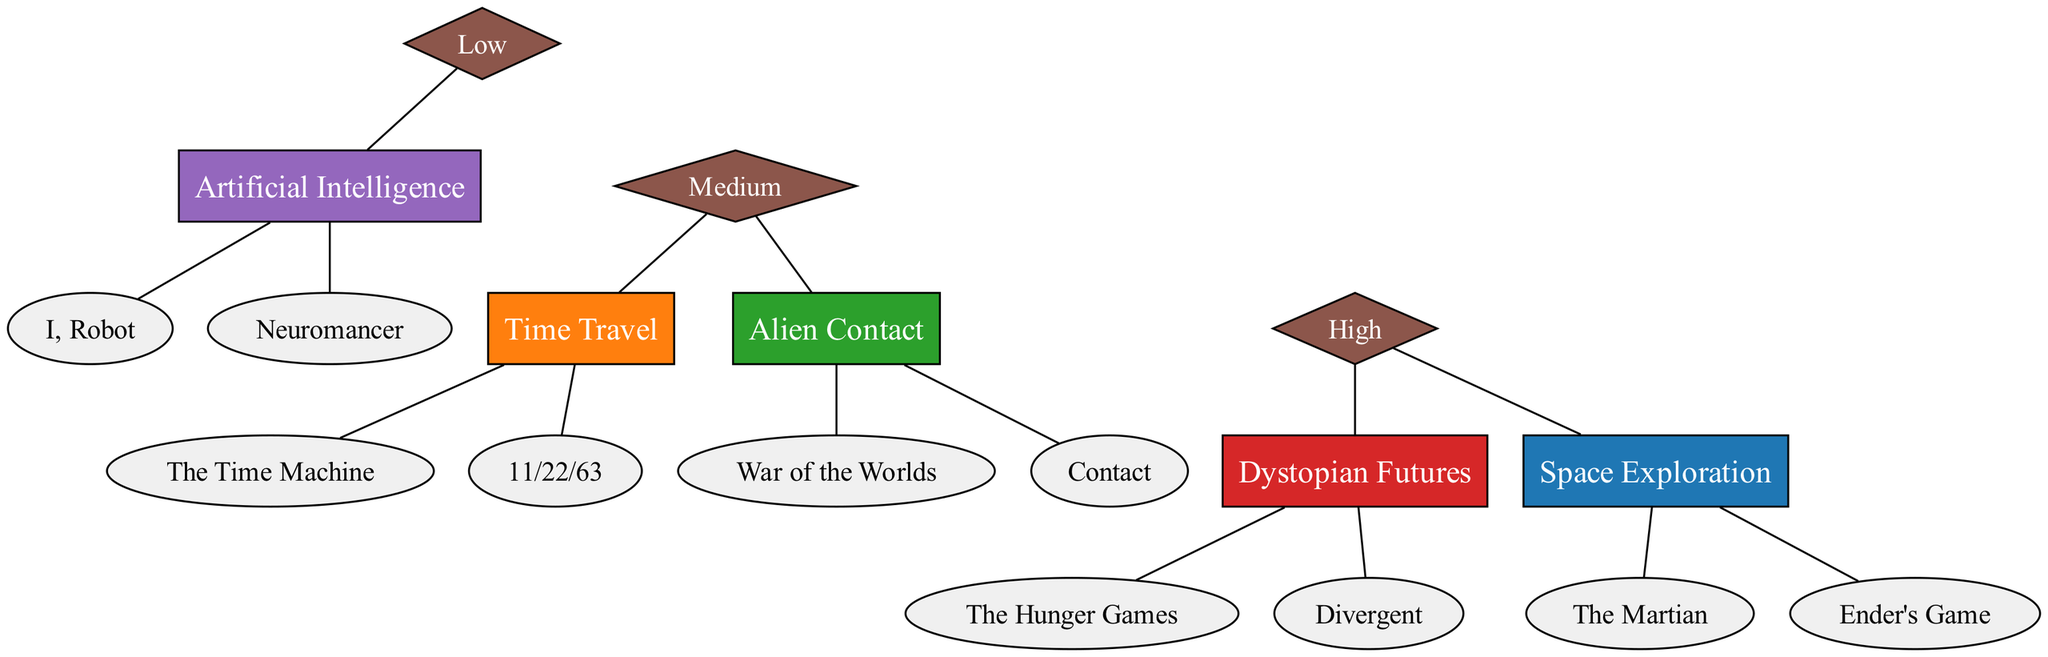What are the themes represented in the diagram? The diagram lists five themes: Space Exploration, Time Travel, Alien Contact, Dystopian Futures, and Artificial Intelligence. Since all themes are displayed as boxes, we can simply enumerate them directly from the nodes labeled in the diagram.
Answer: Space Exploration, Time Travel, Alien Contact, Dystopian Futures, Artificial Intelligence How many books are associated with Dystopian Futures? The theme Dystopian Futures has two associated novels listed underneath it, which are The Hunger Games and Divergent. Counting the books gives us the total.
Answer: 2 Which theme has a "High" prevalence? Upon reviewing the connections, both Space Exploration and Dystopian Futures point to the "High" prevalence node. They are the only themes linked to this designation.
Answer: Space Exploration, Dystopian Futures Which theme is linked to the "Low" prevalence? In the diagram, Artificial Intelligence is explicitly connected to the "Low" prevalence node. This can be confirmed by tracing the edge from the theme to the prevalence.
Answer: Artificial Intelligence How many themes are linked to "Medium" prevalence? There are two themes that connect to the "Medium" prevalence node: Time Travel and Alien Contact. By identifying and counting the edges leading to "Medium," we find this number.
Answer: 2 What is the color assigned to Alien Contact in the diagram? The color scheme in the diagram indicates that Alien Contact is represented in green (#2ca02c). This can be determined by checking the specific color associated with the node for Alien Contact.
Answer: Green What do the diamond-shaped nodes represent in this diagram? Each diamond-shaped node in the diagram represents the prevalence level (High, Medium, Low) of the themes. Their unique shape signifies their categorization as prevalence indicators, differentiating them from the themed boxes.
Answer: Prevalence Which theme is the most prevalent based on the diagram? Analyzing the connections, both Space Exploration and Dystopian Futures are considered high in prevalence. However, since they both fall under "High," we can conclude they are equally prevalent at that level.
Answer: Space Exploration, Dystopian Futures What is the relationship between Time Travel and Alien Contact? The relationship is that both themes share the same prevalence level of "Medium," highlighting that they are both represented within that classification. The direct relationship is observed through their connection to the Medium node.
Answer: Medium 